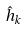Convert formula to latex. <formula><loc_0><loc_0><loc_500><loc_500>\hat { h } _ { k }</formula> 